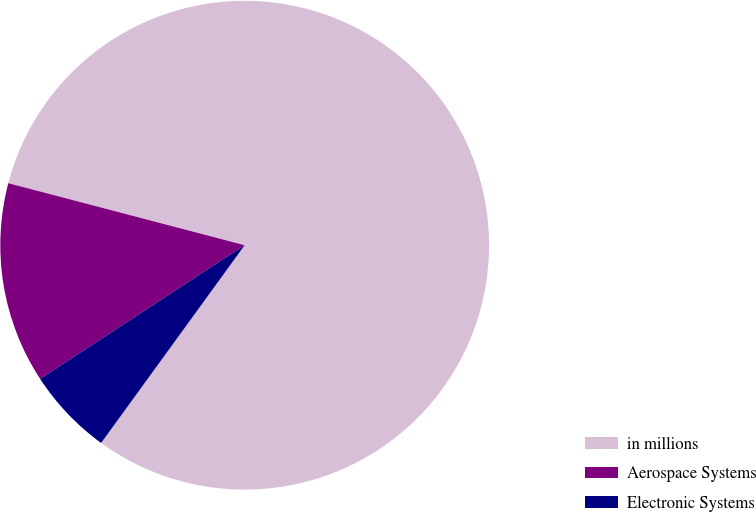Convert chart to OTSL. <chart><loc_0><loc_0><loc_500><loc_500><pie_chart><fcel>in millions<fcel>Aerospace Systems<fcel>Electronic Systems<nl><fcel>80.9%<fcel>13.3%<fcel>5.79%<nl></chart> 